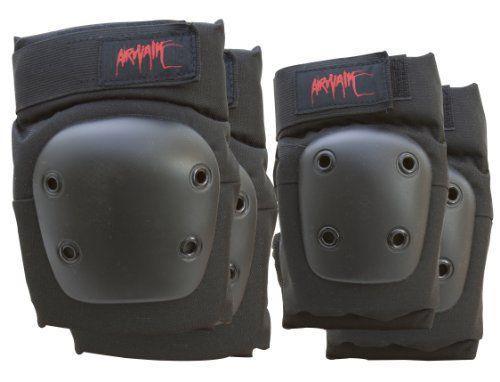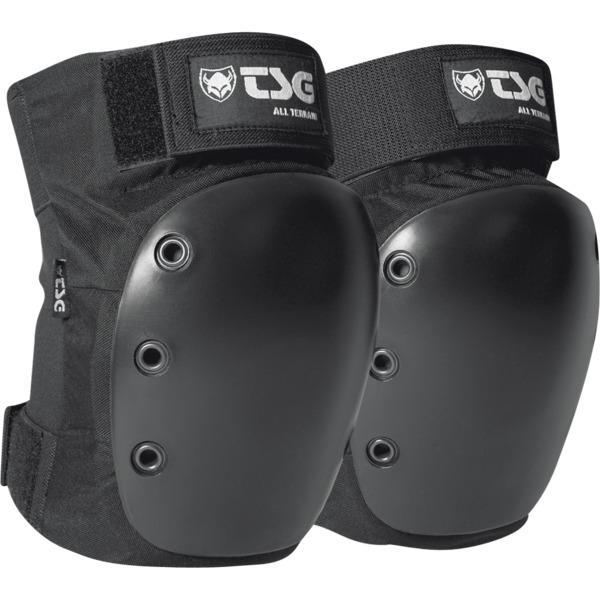The first image is the image on the left, the second image is the image on the right. Considering the images on both sides, is "There are two kneepads with solid red writing across the top of the knee pad." valid? Answer yes or no. Yes. 